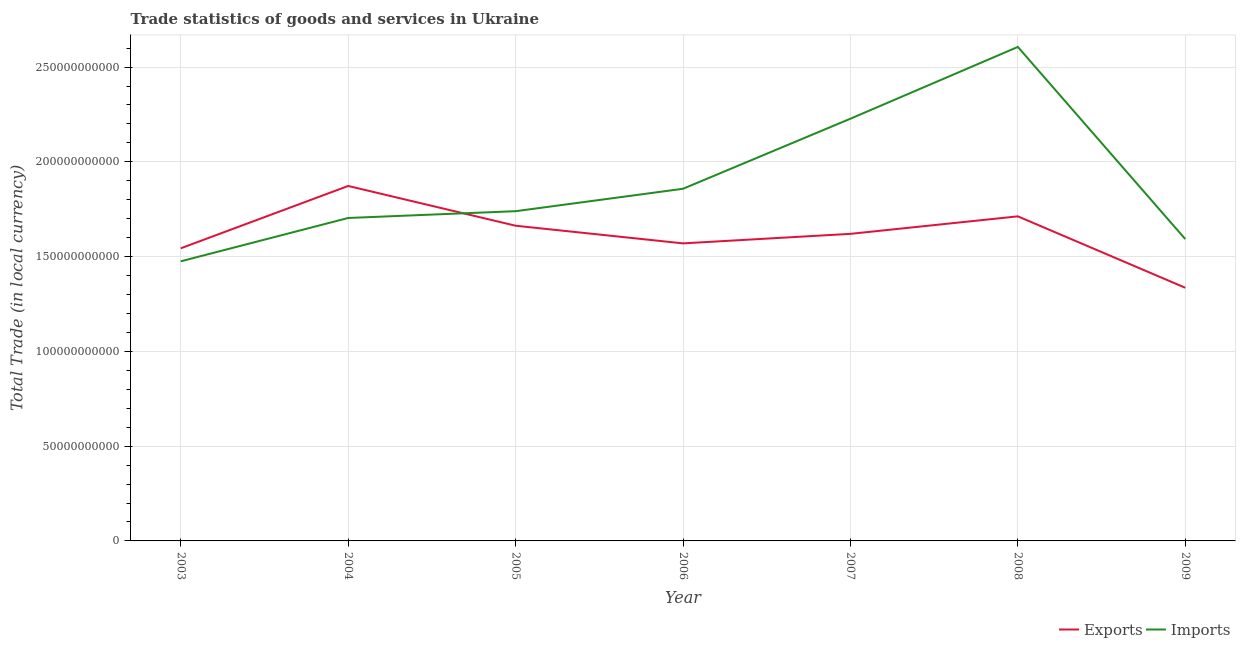How many different coloured lines are there?
Offer a very short reply. 2. Does the line corresponding to export of goods and services intersect with the line corresponding to imports of goods and services?
Ensure brevity in your answer.  Yes. What is the imports of goods and services in 2003?
Your answer should be compact. 1.48e+11. Across all years, what is the maximum export of goods and services?
Give a very brief answer. 1.87e+11. Across all years, what is the minimum imports of goods and services?
Offer a very short reply. 1.48e+11. In which year was the imports of goods and services maximum?
Make the answer very short. 2008. In which year was the export of goods and services minimum?
Ensure brevity in your answer.  2009. What is the total export of goods and services in the graph?
Offer a very short reply. 1.13e+12. What is the difference between the imports of goods and services in 2007 and that in 2009?
Offer a very short reply. 6.35e+1. What is the difference between the imports of goods and services in 2004 and the export of goods and services in 2003?
Ensure brevity in your answer.  1.60e+1. What is the average export of goods and services per year?
Ensure brevity in your answer.  1.62e+11. In the year 2003, what is the difference between the imports of goods and services and export of goods and services?
Your answer should be compact. -6.87e+09. What is the ratio of the export of goods and services in 2004 to that in 2006?
Keep it short and to the point. 1.19. Is the difference between the imports of goods and services in 2003 and 2005 greater than the difference between the export of goods and services in 2003 and 2005?
Offer a very short reply. No. What is the difference between the highest and the second highest export of goods and services?
Keep it short and to the point. 1.60e+1. What is the difference between the highest and the lowest imports of goods and services?
Provide a short and direct response. 1.13e+11. Is the sum of the imports of goods and services in 2005 and 2007 greater than the maximum export of goods and services across all years?
Ensure brevity in your answer.  Yes. Does the imports of goods and services monotonically increase over the years?
Provide a short and direct response. No. How many lines are there?
Provide a succinct answer. 2. Where does the legend appear in the graph?
Your answer should be compact. Bottom right. How many legend labels are there?
Offer a very short reply. 2. What is the title of the graph?
Your response must be concise. Trade statistics of goods and services in Ukraine. Does "From human activities" appear as one of the legend labels in the graph?
Offer a very short reply. No. What is the label or title of the Y-axis?
Your answer should be compact. Total Trade (in local currency). What is the Total Trade (in local currency) of Exports in 2003?
Keep it short and to the point. 1.54e+11. What is the Total Trade (in local currency) of Imports in 2003?
Make the answer very short. 1.48e+11. What is the Total Trade (in local currency) in Exports in 2004?
Make the answer very short. 1.87e+11. What is the Total Trade (in local currency) in Imports in 2004?
Your answer should be compact. 1.70e+11. What is the Total Trade (in local currency) in Exports in 2005?
Offer a terse response. 1.66e+11. What is the Total Trade (in local currency) in Imports in 2005?
Offer a terse response. 1.74e+11. What is the Total Trade (in local currency) of Exports in 2006?
Ensure brevity in your answer.  1.57e+11. What is the Total Trade (in local currency) of Imports in 2006?
Your answer should be very brief. 1.86e+11. What is the Total Trade (in local currency) in Exports in 2007?
Ensure brevity in your answer.  1.62e+11. What is the Total Trade (in local currency) of Imports in 2007?
Offer a terse response. 2.23e+11. What is the Total Trade (in local currency) in Exports in 2008?
Your answer should be compact. 1.71e+11. What is the Total Trade (in local currency) of Imports in 2008?
Your answer should be compact. 2.61e+11. What is the Total Trade (in local currency) in Exports in 2009?
Your answer should be compact. 1.34e+11. What is the Total Trade (in local currency) in Imports in 2009?
Give a very brief answer. 1.59e+11. Across all years, what is the maximum Total Trade (in local currency) of Exports?
Keep it short and to the point. 1.87e+11. Across all years, what is the maximum Total Trade (in local currency) in Imports?
Your answer should be very brief. 2.61e+11. Across all years, what is the minimum Total Trade (in local currency) in Exports?
Your answer should be compact. 1.34e+11. Across all years, what is the minimum Total Trade (in local currency) in Imports?
Your response must be concise. 1.48e+11. What is the total Total Trade (in local currency) in Exports in the graph?
Keep it short and to the point. 1.13e+12. What is the total Total Trade (in local currency) of Imports in the graph?
Offer a very short reply. 1.32e+12. What is the difference between the Total Trade (in local currency) of Exports in 2003 and that in 2004?
Ensure brevity in your answer.  -3.29e+1. What is the difference between the Total Trade (in local currency) in Imports in 2003 and that in 2004?
Keep it short and to the point. -2.29e+1. What is the difference between the Total Trade (in local currency) of Exports in 2003 and that in 2005?
Provide a short and direct response. -1.19e+1. What is the difference between the Total Trade (in local currency) of Imports in 2003 and that in 2005?
Provide a short and direct response. -2.64e+1. What is the difference between the Total Trade (in local currency) in Exports in 2003 and that in 2006?
Keep it short and to the point. -2.60e+09. What is the difference between the Total Trade (in local currency) in Imports in 2003 and that in 2006?
Provide a succinct answer. -3.83e+1. What is the difference between the Total Trade (in local currency) of Exports in 2003 and that in 2007?
Provide a succinct answer. -7.62e+09. What is the difference between the Total Trade (in local currency) in Imports in 2003 and that in 2007?
Provide a succinct answer. -7.52e+1. What is the difference between the Total Trade (in local currency) of Exports in 2003 and that in 2008?
Provide a short and direct response. -1.69e+1. What is the difference between the Total Trade (in local currency) in Imports in 2003 and that in 2008?
Offer a terse response. -1.13e+11. What is the difference between the Total Trade (in local currency) of Exports in 2003 and that in 2009?
Keep it short and to the point. 2.08e+1. What is the difference between the Total Trade (in local currency) in Imports in 2003 and that in 2009?
Offer a very short reply. -1.17e+1. What is the difference between the Total Trade (in local currency) of Exports in 2004 and that in 2005?
Your answer should be compact. 2.10e+1. What is the difference between the Total Trade (in local currency) in Imports in 2004 and that in 2005?
Give a very brief answer. -3.58e+09. What is the difference between the Total Trade (in local currency) of Exports in 2004 and that in 2006?
Your response must be concise. 3.03e+1. What is the difference between the Total Trade (in local currency) of Imports in 2004 and that in 2006?
Offer a terse response. -1.54e+1. What is the difference between the Total Trade (in local currency) of Exports in 2004 and that in 2007?
Give a very brief answer. 2.53e+1. What is the difference between the Total Trade (in local currency) in Imports in 2004 and that in 2007?
Make the answer very short. -5.24e+1. What is the difference between the Total Trade (in local currency) in Exports in 2004 and that in 2008?
Give a very brief answer. 1.60e+1. What is the difference between the Total Trade (in local currency) in Imports in 2004 and that in 2008?
Ensure brevity in your answer.  -9.03e+1. What is the difference between the Total Trade (in local currency) in Exports in 2004 and that in 2009?
Give a very brief answer. 5.37e+1. What is the difference between the Total Trade (in local currency) in Imports in 2004 and that in 2009?
Provide a succinct answer. 1.11e+1. What is the difference between the Total Trade (in local currency) of Exports in 2005 and that in 2006?
Ensure brevity in your answer.  9.31e+09. What is the difference between the Total Trade (in local currency) of Imports in 2005 and that in 2006?
Give a very brief answer. -1.18e+1. What is the difference between the Total Trade (in local currency) in Exports in 2005 and that in 2007?
Provide a short and direct response. 4.29e+09. What is the difference between the Total Trade (in local currency) of Imports in 2005 and that in 2007?
Your response must be concise. -4.88e+1. What is the difference between the Total Trade (in local currency) in Exports in 2005 and that in 2008?
Offer a very short reply. -4.95e+09. What is the difference between the Total Trade (in local currency) of Imports in 2005 and that in 2008?
Provide a short and direct response. -8.67e+1. What is the difference between the Total Trade (in local currency) in Exports in 2005 and that in 2009?
Ensure brevity in your answer.  3.27e+1. What is the difference between the Total Trade (in local currency) of Imports in 2005 and that in 2009?
Make the answer very short. 1.47e+1. What is the difference between the Total Trade (in local currency) in Exports in 2006 and that in 2007?
Keep it short and to the point. -5.02e+09. What is the difference between the Total Trade (in local currency) of Imports in 2006 and that in 2007?
Give a very brief answer. -3.70e+1. What is the difference between the Total Trade (in local currency) in Exports in 2006 and that in 2008?
Give a very brief answer. -1.43e+1. What is the difference between the Total Trade (in local currency) of Imports in 2006 and that in 2008?
Provide a succinct answer. -7.48e+1. What is the difference between the Total Trade (in local currency) in Exports in 2006 and that in 2009?
Ensure brevity in your answer.  2.34e+1. What is the difference between the Total Trade (in local currency) of Imports in 2006 and that in 2009?
Your response must be concise. 2.65e+1. What is the difference between the Total Trade (in local currency) in Exports in 2007 and that in 2008?
Keep it short and to the point. -9.23e+09. What is the difference between the Total Trade (in local currency) of Imports in 2007 and that in 2008?
Give a very brief answer. -3.79e+1. What is the difference between the Total Trade (in local currency) of Exports in 2007 and that in 2009?
Offer a very short reply. 2.84e+1. What is the difference between the Total Trade (in local currency) in Imports in 2007 and that in 2009?
Keep it short and to the point. 6.35e+1. What is the difference between the Total Trade (in local currency) in Exports in 2008 and that in 2009?
Provide a succinct answer. 3.77e+1. What is the difference between the Total Trade (in local currency) of Imports in 2008 and that in 2009?
Your answer should be compact. 1.01e+11. What is the difference between the Total Trade (in local currency) of Exports in 2003 and the Total Trade (in local currency) of Imports in 2004?
Keep it short and to the point. -1.60e+1. What is the difference between the Total Trade (in local currency) of Exports in 2003 and the Total Trade (in local currency) of Imports in 2005?
Give a very brief answer. -1.96e+1. What is the difference between the Total Trade (in local currency) of Exports in 2003 and the Total Trade (in local currency) of Imports in 2006?
Ensure brevity in your answer.  -3.14e+1. What is the difference between the Total Trade (in local currency) in Exports in 2003 and the Total Trade (in local currency) in Imports in 2007?
Make the answer very short. -6.84e+1. What is the difference between the Total Trade (in local currency) of Exports in 2003 and the Total Trade (in local currency) of Imports in 2008?
Your response must be concise. -1.06e+11. What is the difference between the Total Trade (in local currency) of Exports in 2003 and the Total Trade (in local currency) of Imports in 2009?
Offer a terse response. -4.86e+09. What is the difference between the Total Trade (in local currency) of Exports in 2004 and the Total Trade (in local currency) of Imports in 2005?
Ensure brevity in your answer.  1.33e+1. What is the difference between the Total Trade (in local currency) in Exports in 2004 and the Total Trade (in local currency) in Imports in 2006?
Provide a short and direct response. 1.48e+09. What is the difference between the Total Trade (in local currency) in Exports in 2004 and the Total Trade (in local currency) in Imports in 2007?
Offer a terse response. -3.55e+1. What is the difference between the Total Trade (in local currency) in Exports in 2004 and the Total Trade (in local currency) in Imports in 2008?
Offer a very short reply. -7.34e+1. What is the difference between the Total Trade (in local currency) of Exports in 2004 and the Total Trade (in local currency) of Imports in 2009?
Keep it short and to the point. 2.80e+1. What is the difference between the Total Trade (in local currency) of Exports in 2005 and the Total Trade (in local currency) of Imports in 2006?
Provide a short and direct response. -1.95e+1. What is the difference between the Total Trade (in local currency) of Exports in 2005 and the Total Trade (in local currency) of Imports in 2007?
Keep it short and to the point. -5.65e+1. What is the difference between the Total Trade (in local currency) in Exports in 2005 and the Total Trade (in local currency) in Imports in 2008?
Make the answer very short. -9.43e+1. What is the difference between the Total Trade (in local currency) of Exports in 2005 and the Total Trade (in local currency) of Imports in 2009?
Offer a terse response. 7.05e+09. What is the difference between the Total Trade (in local currency) of Exports in 2006 and the Total Trade (in local currency) of Imports in 2007?
Ensure brevity in your answer.  -6.58e+1. What is the difference between the Total Trade (in local currency) in Exports in 2006 and the Total Trade (in local currency) in Imports in 2008?
Your answer should be compact. -1.04e+11. What is the difference between the Total Trade (in local currency) in Exports in 2006 and the Total Trade (in local currency) in Imports in 2009?
Provide a succinct answer. -2.26e+09. What is the difference between the Total Trade (in local currency) of Exports in 2007 and the Total Trade (in local currency) of Imports in 2008?
Give a very brief answer. -9.86e+1. What is the difference between the Total Trade (in local currency) of Exports in 2007 and the Total Trade (in local currency) of Imports in 2009?
Keep it short and to the point. 2.76e+09. What is the difference between the Total Trade (in local currency) in Exports in 2008 and the Total Trade (in local currency) in Imports in 2009?
Provide a succinct answer. 1.20e+1. What is the average Total Trade (in local currency) in Exports per year?
Offer a terse response. 1.62e+11. What is the average Total Trade (in local currency) of Imports per year?
Provide a short and direct response. 1.89e+11. In the year 2003, what is the difference between the Total Trade (in local currency) in Exports and Total Trade (in local currency) in Imports?
Keep it short and to the point. 6.87e+09. In the year 2004, what is the difference between the Total Trade (in local currency) of Exports and Total Trade (in local currency) of Imports?
Provide a succinct answer. 1.69e+1. In the year 2005, what is the difference between the Total Trade (in local currency) of Exports and Total Trade (in local currency) of Imports?
Offer a very short reply. -7.67e+09. In the year 2006, what is the difference between the Total Trade (in local currency) of Exports and Total Trade (in local currency) of Imports?
Offer a terse response. -2.88e+1. In the year 2007, what is the difference between the Total Trade (in local currency) of Exports and Total Trade (in local currency) of Imports?
Your answer should be compact. -6.08e+1. In the year 2008, what is the difference between the Total Trade (in local currency) of Exports and Total Trade (in local currency) of Imports?
Your answer should be compact. -8.94e+1. In the year 2009, what is the difference between the Total Trade (in local currency) in Exports and Total Trade (in local currency) in Imports?
Ensure brevity in your answer.  -2.57e+1. What is the ratio of the Total Trade (in local currency) of Exports in 2003 to that in 2004?
Your response must be concise. 0.82. What is the ratio of the Total Trade (in local currency) in Imports in 2003 to that in 2004?
Give a very brief answer. 0.87. What is the ratio of the Total Trade (in local currency) of Exports in 2003 to that in 2005?
Ensure brevity in your answer.  0.93. What is the ratio of the Total Trade (in local currency) in Imports in 2003 to that in 2005?
Offer a very short reply. 0.85. What is the ratio of the Total Trade (in local currency) in Exports in 2003 to that in 2006?
Keep it short and to the point. 0.98. What is the ratio of the Total Trade (in local currency) of Imports in 2003 to that in 2006?
Provide a short and direct response. 0.79. What is the ratio of the Total Trade (in local currency) of Exports in 2003 to that in 2007?
Ensure brevity in your answer.  0.95. What is the ratio of the Total Trade (in local currency) of Imports in 2003 to that in 2007?
Your response must be concise. 0.66. What is the ratio of the Total Trade (in local currency) of Exports in 2003 to that in 2008?
Provide a short and direct response. 0.9. What is the ratio of the Total Trade (in local currency) of Imports in 2003 to that in 2008?
Give a very brief answer. 0.57. What is the ratio of the Total Trade (in local currency) in Exports in 2003 to that in 2009?
Make the answer very short. 1.16. What is the ratio of the Total Trade (in local currency) in Imports in 2003 to that in 2009?
Your answer should be very brief. 0.93. What is the ratio of the Total Trade (in local currency) in Exports in 2004 to that in 2005?
Your answer should be compact. 1.13. What is the ratio of the Total Trade (in local currency) in Imports in 2004 to that in 2005?
Provide a short and direct response. 0.98. What is the ratio of the Total Trade (in local currency) of Exports in 2004 to that in 2006?
Give a very brief answer. 1.19. What is the ratio of the Total Trade (in local currency) of Imports in 2004 to that in 2006?
Offer a very short reply. 0.92. What is the ratio of the Total Trade (in local currency) of Exports in 2004 to that in 2007?
Your answer should be compact. 1.16. What is the ratio of the Total Trade (in local currency) in Imports in 2004 to that in 2007?
Provide a succinct answer. 0.76. What is the ratio of the Total Trade (in local currency) of Exports in 2004 to that in 2008?
Your response must be concise. 1.09. What is the ratio of the Total Trade (in local currency) of Imports in 2004 to that in 2008?
Give a very brief answer. 0.65. What is the ratio of the Total Trade (in local currency) of Exports in 2004 to that in 2009?
Your answer should be compact. 1.4. What is the ratio of the Total Trade (in local currency) in Imports in 2004 to that in 2009?
Keep it short and to the point. 1.07. What is the ratio of the Total Trade (in local currency) of Exports in 2005 to that in 2006?
Give a very brief answer. 1.06. What is the ratio of the Total Trade (in local currency) of Imports in 2005 to that in 2006?
Provide a succinct answer. 0.94. What is the ratio of the Total Trade (in local currency) in Exports in 2005 to that in 2007?
Your answer should be very brief. 1.03. What is the ratio of the Total Trade (in local currency) of Imports in 2005 to that in 2007?
Provide a succinct answer. 0.78. What is the ratio of the Total Trade (in local currency) in Exports in 2005 to that in 2008?
Keep it short and to the point. 0.97. What is the ratio of the Total Trade (in local currency) in Imports in 2005 to that in 2008?
Keep it short and to the point. 0.67. What is the ratio of the Total Trade (in local currency) in Exports in 2005 to that in 2009?
Offer a very short reply. 1.25. What is the ratio of the Total Trade (in local currency) of Imports in 2005 to that in 2009?
Ensure brevity in your answer.  1.09. What is the ratio of the Total Trade (in local currency) in Exports in 2006 to that in 2007?
Keep it short and to the point. 0.97. What is the ratio of the Total Trade (in local currency) in Imports in 2006 to that in 2007?
Ensure brevity in your answer.  0.83. What is the ratio of the Total Trade (in local currency) in Imports in 2006 to that in 2008?
Offer a very short reply. 0.71. What is the ratio of the Total Trade (in local currency) in Exports in 2006 to that in 2009?
Keep it short and to the point. 1.18. What is the ratio of the Total Trade (in local currency) in Exports in 2007 to that in 2008?
Keep it short and to the point. 0.95. What is the ratio of the Total Trade (in local currency) of Imports in 2007 to that in 2008?
Offer a very short reply. 0.85. What is the ratio of the Total Trade (in local currency) in Exports in 2007 to that in 2009?
Your answer should be very brief. 1.21. What is the ratio of the Total Trade (in local currency) of Imports in 2007 to that in 2009?
Offer a terse response. 1.4. What is the ratio of the Total Trade (in local currency) in Exports in 2008 to that in 2009?
Provide a short and direct response. 1.28. What is the ratio of the Total Trade (in local currency) of Imports in 2008 to that in 2009?
Offer a very short reply. 1.64. What is the difference between the highest and the second highest Total Trade (in local currency) in Exports?
Provide a short and direct response. 1.60e+1. What is the difference between the highest and the second highest Total Trade (in local currency) in Imports?
Give a very brief answer. 3.79e+1. What is the difference between the highest and the lowest Total Trade (in local currency) of Exports?
Provide a succinct answer. 5.37e+1. What is the difference between the highest and the lowest Total Trade (in local currency) of Imports?
Offer a very short reply. 1.13e+11. 